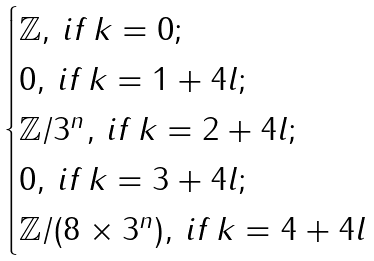<formula> <loc_0><loc_0><loc_500><loc_500>\begin{cases} \mathbb { Z } , \, i f \, k = 0 ; \\ 0 , \, i f \, k = 1 + 4 l ; \\ \mathbb { Z } / 3 ^ { n } , \, i f \, k = 2 + 4 l ; \\ 0 , \, i f \, k = 3 + 4 l ; \\ \mathbb { Z } / ( 8 \times 3 ^ { n } ) , \, i f \, k = 4 + 4 l \end{cases}</formula> 